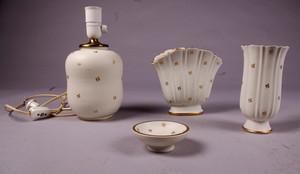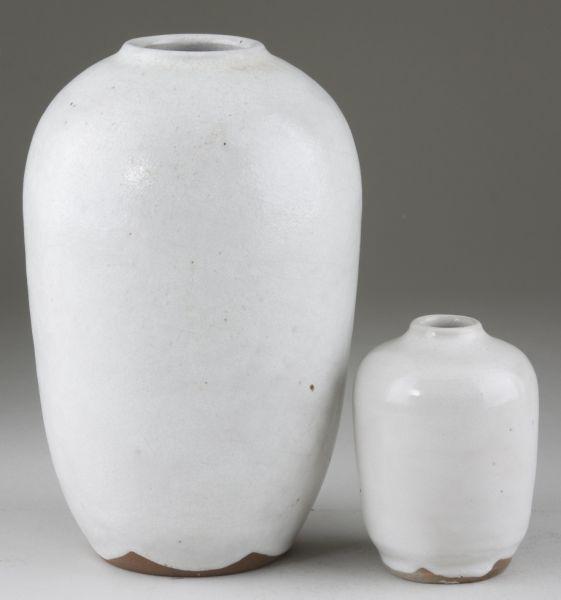The first image is the image on the left, the second image is the image on the right. Assess this claim about the two images: "There are four white vases standing in groups of two.". Correct or not? Answer yes or no. No. The first image is the image on the left, the second image is the image on the right. For the images shown, is this caption "There are four pieces of pottery with four holes." true? Answer yes or no. No. 